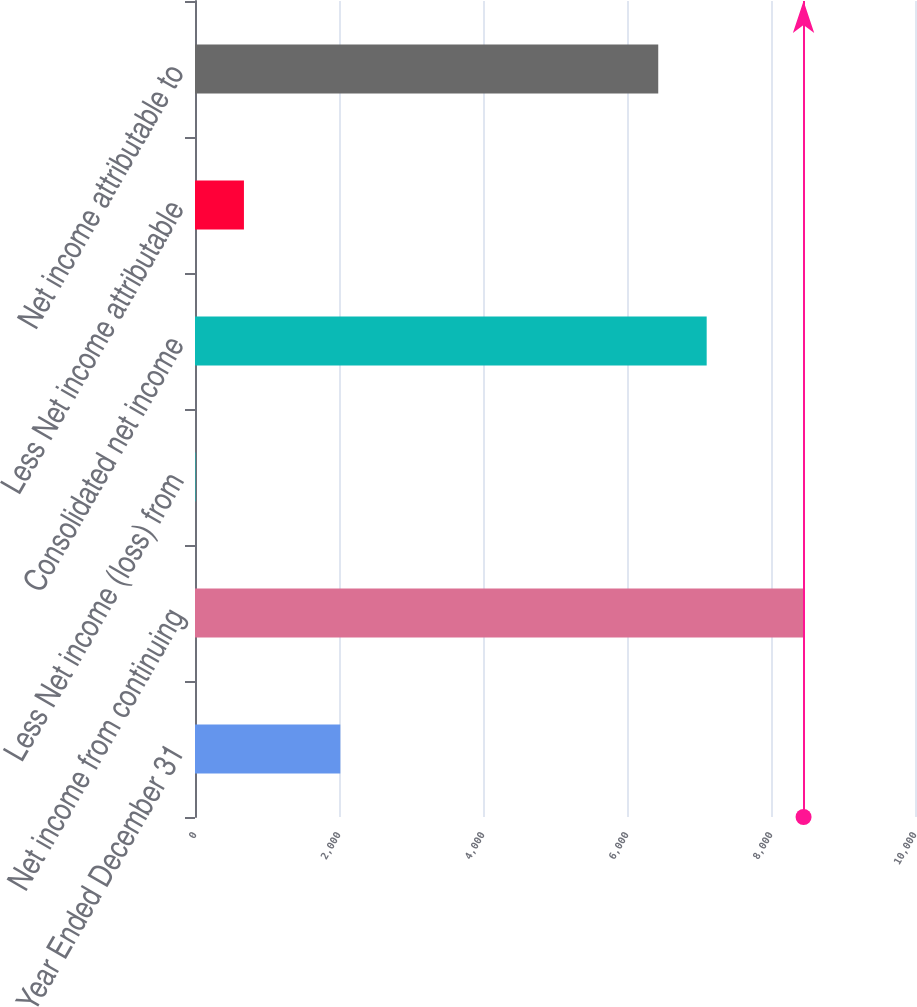Convert chart. <chart><loc_0><loc_0><loc_500><loc_500><bar_chart><fcel>Year Ended December 31<fcel>Net income from continuing<fcel>Less Net income (loss) from<fcel>Consolidated net income<fcel>Less Net income attributable<fcel>Net income attributable to<nl><fcel>2018<fcel>8452.1<fcel>7<fcel>7106.7<fcel>679.7<fcel>6434<nl></chart> 